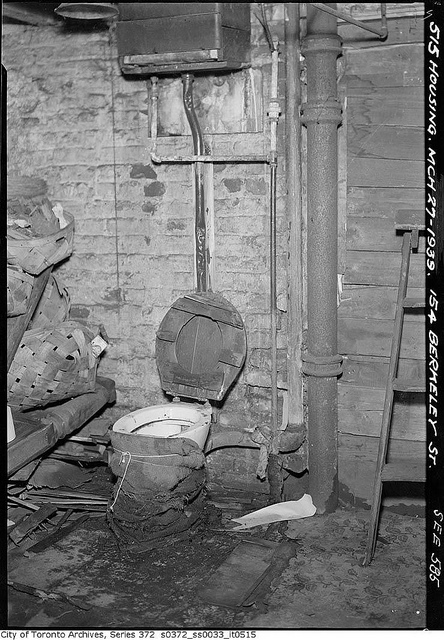Please extract the text content from this image. 515 HOUSING. MCH 27-1939 154 BERKELEY ST SEE 585 